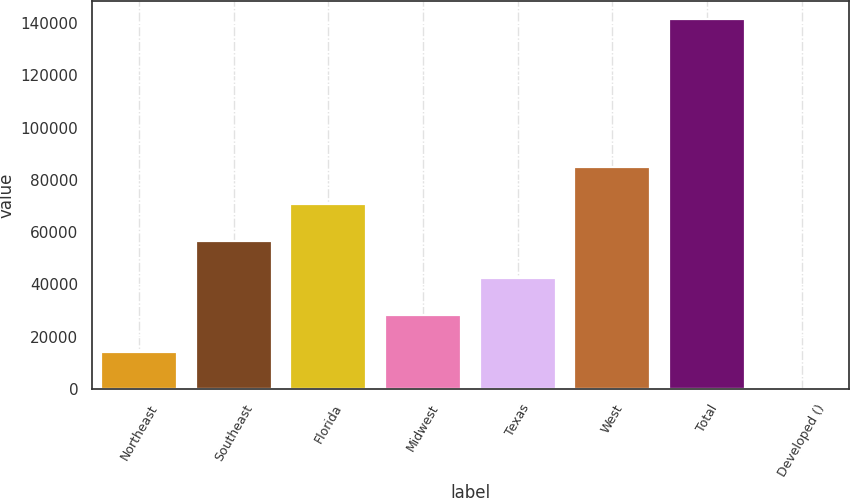Convert chart. <chart><loc_0><loc_0><loc_500><loc_500><bar_chart><fcel>Northeast<fcel>Southeast<fcel>Florida<fcel>Midwest<fcel>Texas<fcel>West<fcel>Total<fcel>Developed ()<nl><fcel>14168.8<fcel>56582.2<fcel>70720<fcel>28306.6<fcel>42444.4<fcel>84857.8<fcel>141409<fcel>31<nl></chart> 